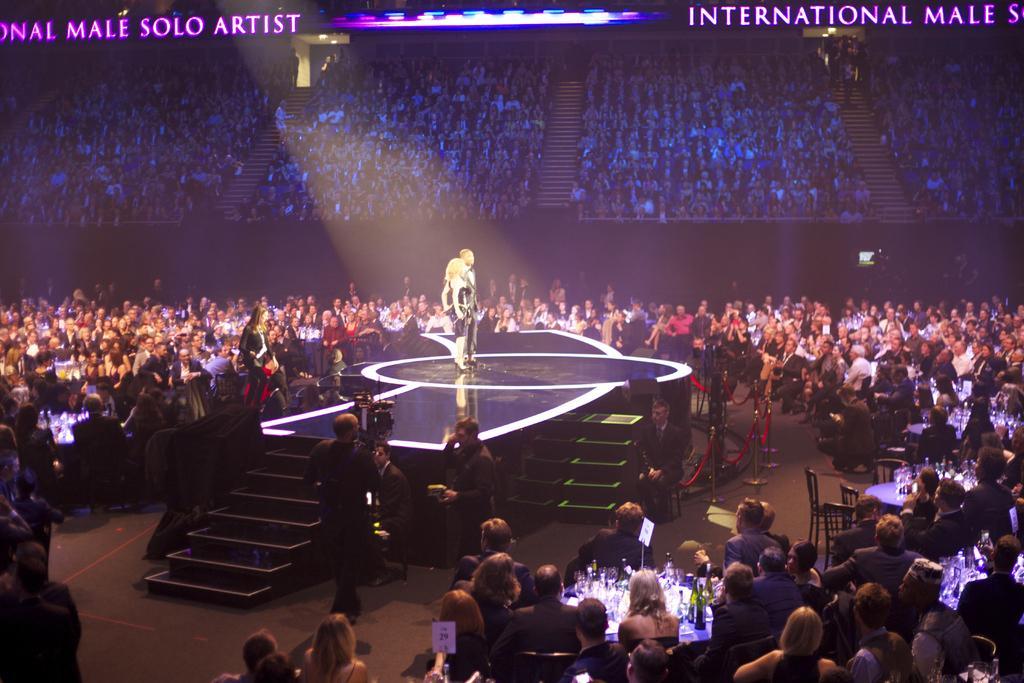Can you describe this image briefly? In the image in the center we can see one stage. On the stage,we can see two persons were standing. And we can see staircases,chairs,tables and group of people were sitting and standing. On the table,we can see wine bottles. In the background there is a screen. 